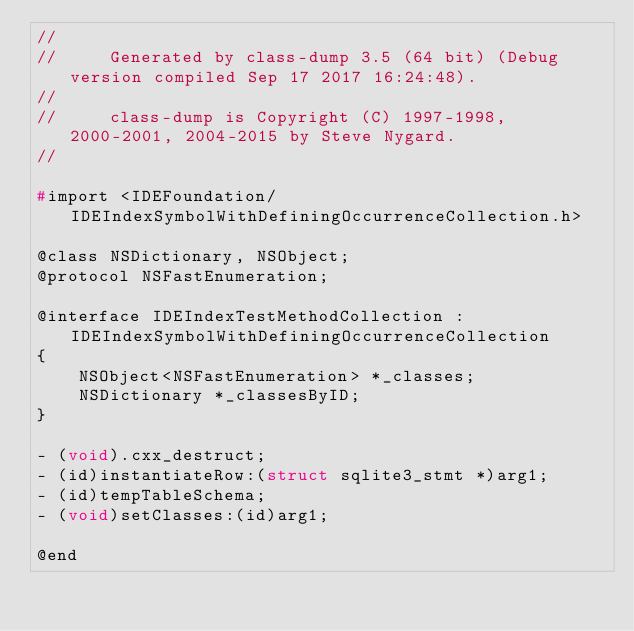<code> <loc_0><loc_0><loc_500><loc_500><_C_>//
//     Generated by class-dump 3.5 (64 bit) (Debug version compiled Sep 17 2017 16:24:48).
//
//     class-dump is Copyright (C) 1997-1998, 2000-2001, 2004-2015 by Steve Nygard.
//

#import <IDEFoundation/IDEIndexSymbolWithDefiningOccurrenceCollection.h>

@class NSDictionary, NSObject;
@protocol NSFastEnumeration;

@interface IDEIndexTestMethodCollection : IDEIndexSymbolWithDefiningOccurrenceCollection
{
    NSObject<NSFastEnumeration> *_classes;
    NSDictionary *_classesByID;
}

- (void).cxx_destruct;
- (id)instantiateRow:(struct sqlite3_stmt *)arg1;
- (id)tempTableSchema;
- (void)setClasses:(id)arg1;

@end

</code> 